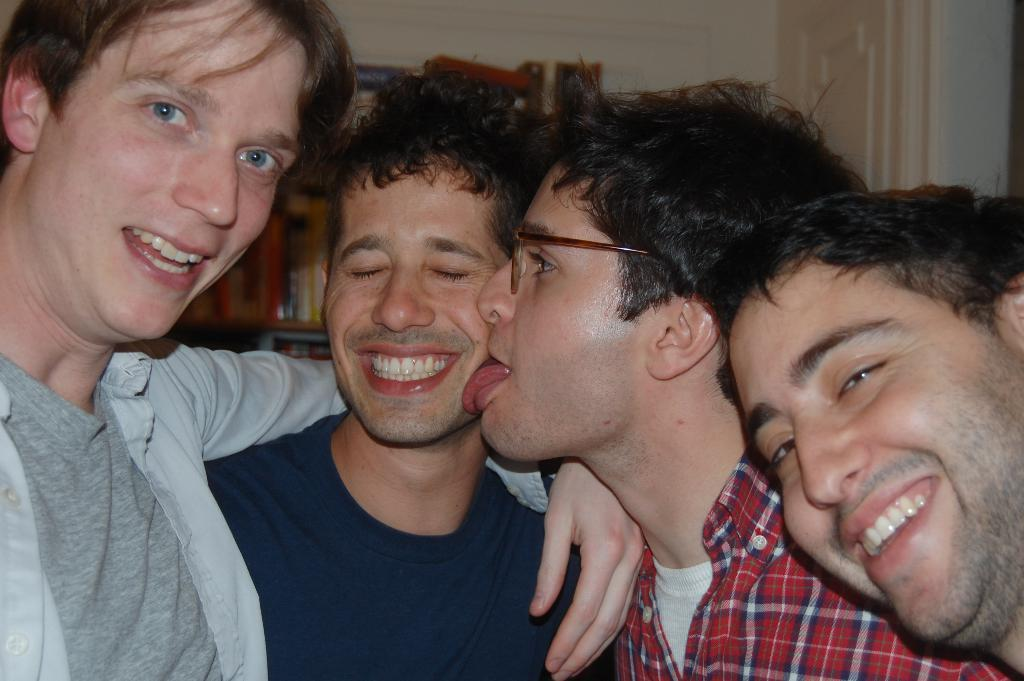Who or what is present in the image? There are people in the image. What can be seen on the shelf in the background? There is a shelf with books in the background. What architectural feature is visible in the background? There is a door in the background. What type of surface is present in the background? There is a wall in the background. How much money is on the table in the image? There is no mention of money or a table in the image, so it cannot be determined from the provided facts. 